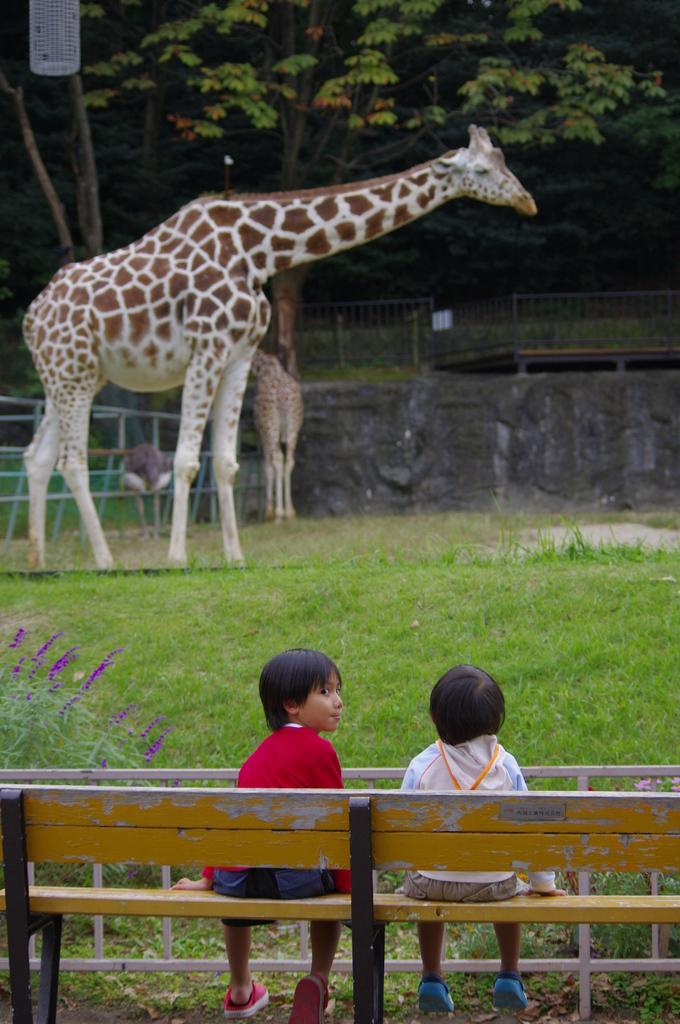How many people are sitting on the bench in the image? There are two people sitting on a bench in the image. What is in front of the people on the bench? There are two animals in front of the people. What can be seen at the back of the image? There is a tree and a railing visible at the back of the image. What type of eggs can be seen on the railing in the image? There are no eggs visible on the railing in the image. What color is the ink used to write on the tree in the image? There is no writing or ink present on the tree in the image. 